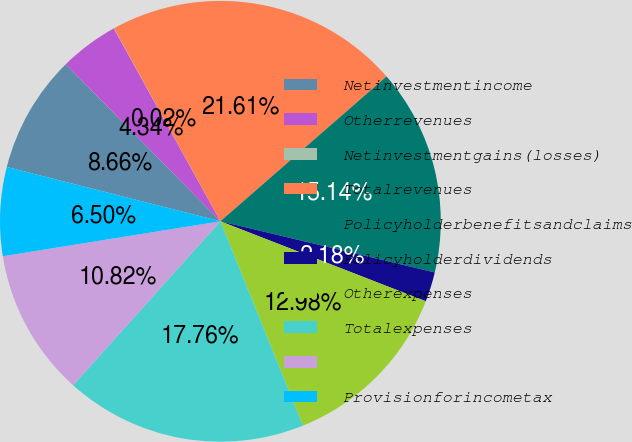Convert chart to OTSL. <chart><loc_0><loc_0><loc_500><loc_500><pie_chart><fcel>Netinvestmentincome<fcel>Otherrevenues<fcel>Netinvestmentgains(losses)<fcel>Totalrevenues<fcel>Policyholderbenefitsandclaims<fcel>Policyholderdividends<fcel>Otherexpenses<fcel>Totalexpenses<fcel>Unnamed: 8<fcel>Provisionforincometax<nl><fcel>8.66%<fcel>4.34%<fcel>0.02%<fcel>21.61%<fcel>15.14%<fcel>2.18%<fcel>12.98%<fcel>17.76%<fcel>10.82%<fcel>6.5%<nl></chart> 